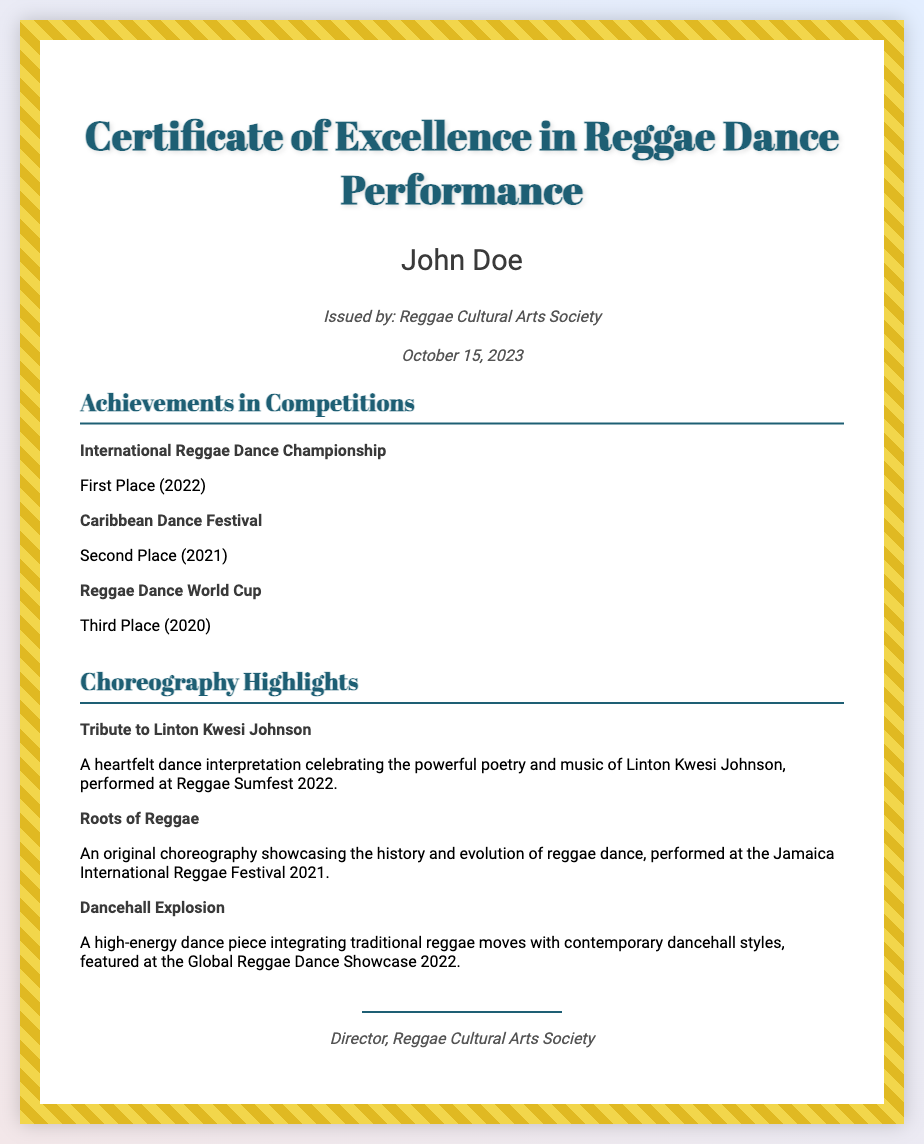what is the title of the certificate? The title, prominently displayed at the top of the document, describes the purpose of the certificate.
Answer: Certificate of Excellence in Reggae Dance Performance who is the recipient of this certificate? The recipient's name is stated clearly on the certificate, identifying the individual recognized for achievements.
Answer: John Doe what organization issued the certificate? This information is found near the name of the recipient, indicating the body responsible for the award.
Answer: Reggae Cultural Arts Society when was the certificate issued? The date of issuance is provided on the document, indicating when the recognition was formally granted.
Answer: October 15, 2023 which competition did the recipient place first in? This information is listed in the achievements section, indicating specific accolades received by the recipient.
Answer: International Reggae Dance Championship what was the title of the tribute dance performed at Reggae Sumfest 2022? The title of the performance is included in the choreography highlights, showcasing a specific artistic expression related to an influential figure.
Answer: Tribute to Linton Kwesi Johnson what place did the recipient achieve in the Caribbean Dance Festival? This information pertains to the recipient's accomplishments in competitive dancing, found in the achievements section.
Answer: Second Place how many major performances are highlighted in the choreography section? The number of performances can be determined by counting the entries in the provided section.
Answer: Three who signed the certificate? The signature section at the bottom reveals the title of the individual who authorized the document.
Answer: Director, Reggae Cultural Arts Society 